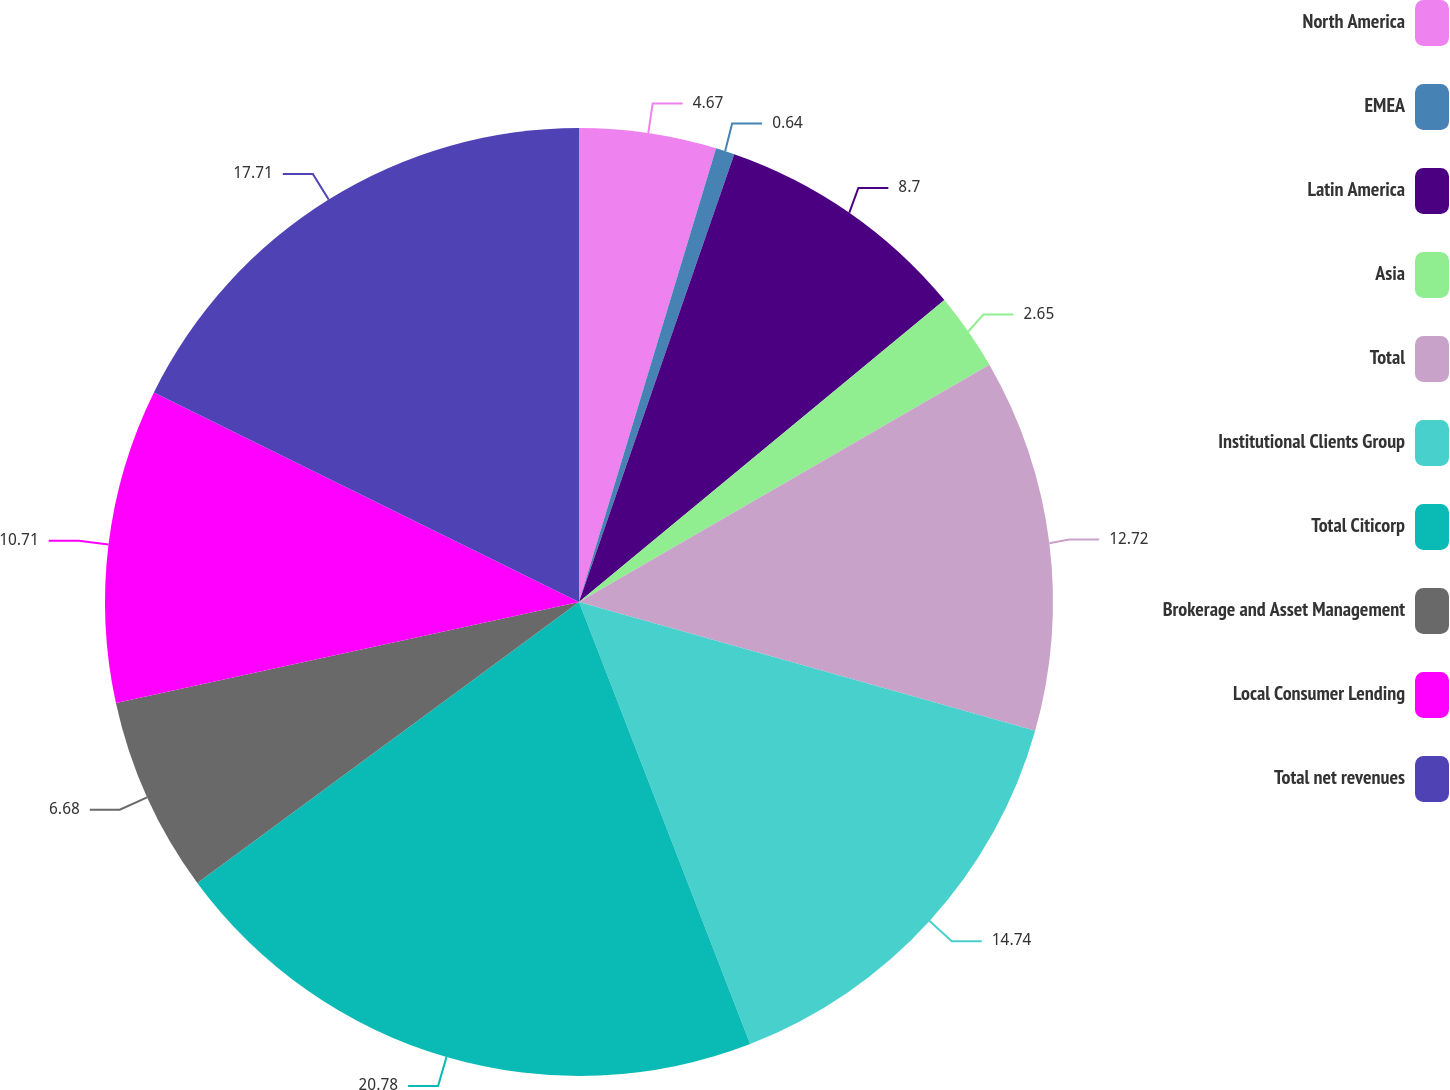<chart> <loc_0><loc_0><loc_500><loc_500><pie_chart><fcel>North America<fcel>EMEA<fcel>Latin America<fcel>Asia<fcel>Total<fcel>Institutional Clients Group<fcel>Total Citicorp<fcel>Brokerage and Asset Management<fcel>Local Consumer Lending<fcel>Total net revenues<nl><fcel>4.67%<fcel>0.64%<fcel>8.7%<fcel>2.65%<fcel>12.72%<fcel>14.74%<fcel>20.78%<fcel>6.68%<fcel>10.71%<fcel>17.71%<nl></chart> 